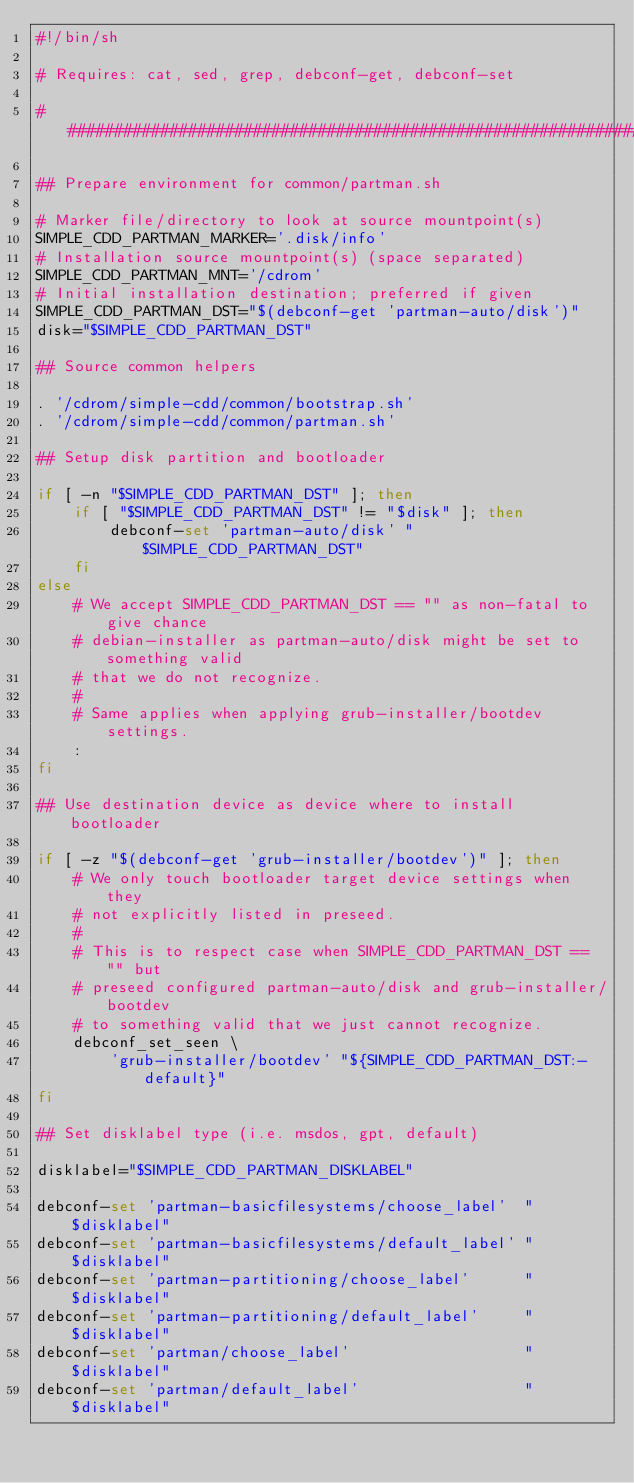<code> <loc_0><loc_0><loc_500><loc_500><_Bash_>#!/bin/sh

# Requires: cat, sed, grep, debconf-get, debconf-set

################################################################################

## Prepare environment for common/partman.sh

# Marker file/directory to look at source mountpoint(s)
SIMPLE_CDD_PARTMAN_MARKER='.disk/info'
# Installation source mountpoint(s) (space separated)
SIMPLE_CDD_PARTMAN_MNT='/cdrom'
# Initial installation destination; preferred if given
SIMPLE_CDD_PARTMAN_DST="$(debconf-get 'partman-auto/disk')"
disk="$SIMPLE_CDD_PARTMAN_DST"

## Source common helpers

. '/cdrom/simple-cdd/common/bootstrap.sh'
. '/cdrom/simple-cdd/common/partman.sh'

## Setup disk partition and bootloader

if [ -n "$SIMPLE_CDD_PARTMAN_DST" ]; then
    if [ "$SIMPLE_CDD_PARTMAN_DST" != "$disk" ]; then
        debconf-set 'partman-auto/disk' "$SIMPLE_CDD_PARTMAN_DST"
    fi
else
    # We accept SIMPLE_CDD_PARTMAN_DST == "" as non-fatal to give chance
    # debian-installer as partman-auto/disk might be set to something valid
    # that we do not recognize.
    #
    # Same applies when applying grub-installer/bootdev settings.
    :
fi

## Use destination device as device where to install bootloader

if [ -z "$(debconf-get 'grub-installer/bootdev')" ]; then
    # We only touch bootloader target device settings when they
    # not explicitly listed in preseed.
    #
    # This is to respect case when SIMPLE_CDD_PARTMAN_DST == "" but
    # preseed configured partman-auto/disk and grub-installer/bootdev
    # to something valid that we just cannot recognize.
    debconf_set_seen \
        'grub-installer/bootdev' "${SIMPLE_CDD_PARTMAN_DST:-default}"
fi

## Set disklabel type (i.e. msdos, gpt, default)

disklabel="$SIMPLE_CDD_PARTMAN_DISKLABEL"

debconf-set 'partman-basicfilesystems/choose_label'  "$disklabel"
debconf-set 'partman-basicfilesystems/default_label' "$disklabel"
debconf-set 'partman-partitioning/choose_label'      "$disklabel"
debconf-set 'partman-partitioning/default_label'     "$disklabel"
debconf-set 'partman/choose_label'                   "$disklabel"
debconf-set 'partman/default_label'                  "$disklabel"
</code> 